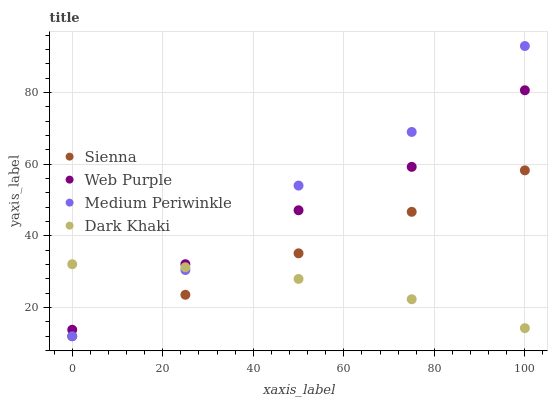Does Dark Khaki have the minimum area under the curve?
Answer yes or no. Yes. Does Medium Periwinkle have the maximum area under the curve?
Answer yes or no. Yes. Does Web Purple have the minimum area under the curve?
Answer yes or no. No. Does Web Purple have the maximum area under the curve?
Answer yes or no. No. Is Sienna the smoothest?
Answer yes or no. Yes. Is Medium Periwinkle the roughest?
Answer yes or no. Yes. Is Dark Khaki the smoothest?
Answer yes or no. No. Is Dark Khaki the roughest?
Answer yes or no. No. Does Sienna have the lowest value?
Answer yes or no. Yes. Does Web Purple have the lowest value?
Answer yes or no. No. Does Medium Periwinkle have the highest value?
Answer yes or no. Yes. Does Web Purple have the highest value?
Answer yes or no. No. Is Sienna less than Web Purple?
Answer yes or no. Yes. Is Web Purple greater than Sienna?
Answer yes or no. Yes. Does Medium Periwinkle intersect Web Purple?
Answer yes or no. Yes. Is Medium Periwinkle less than Web Purple?
Answer yes or no. No. Is Medium Periwinkle greater than Web Purple?
Answer yes or no. No. Does Sienna intersect Web Purple?
Answer yes or no. No. 